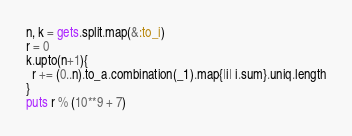<code> <loc_0><loc_0><loc_500><loc_500><_Ruby_>n, k = gets.split.map(&:to_i)
r = 0
k.upto(n+1){
  r += (0..n).to_a.combination(_1).map{|i| i.sum}.uniq.length
}
puts r % (10**9 + 7)</code> 